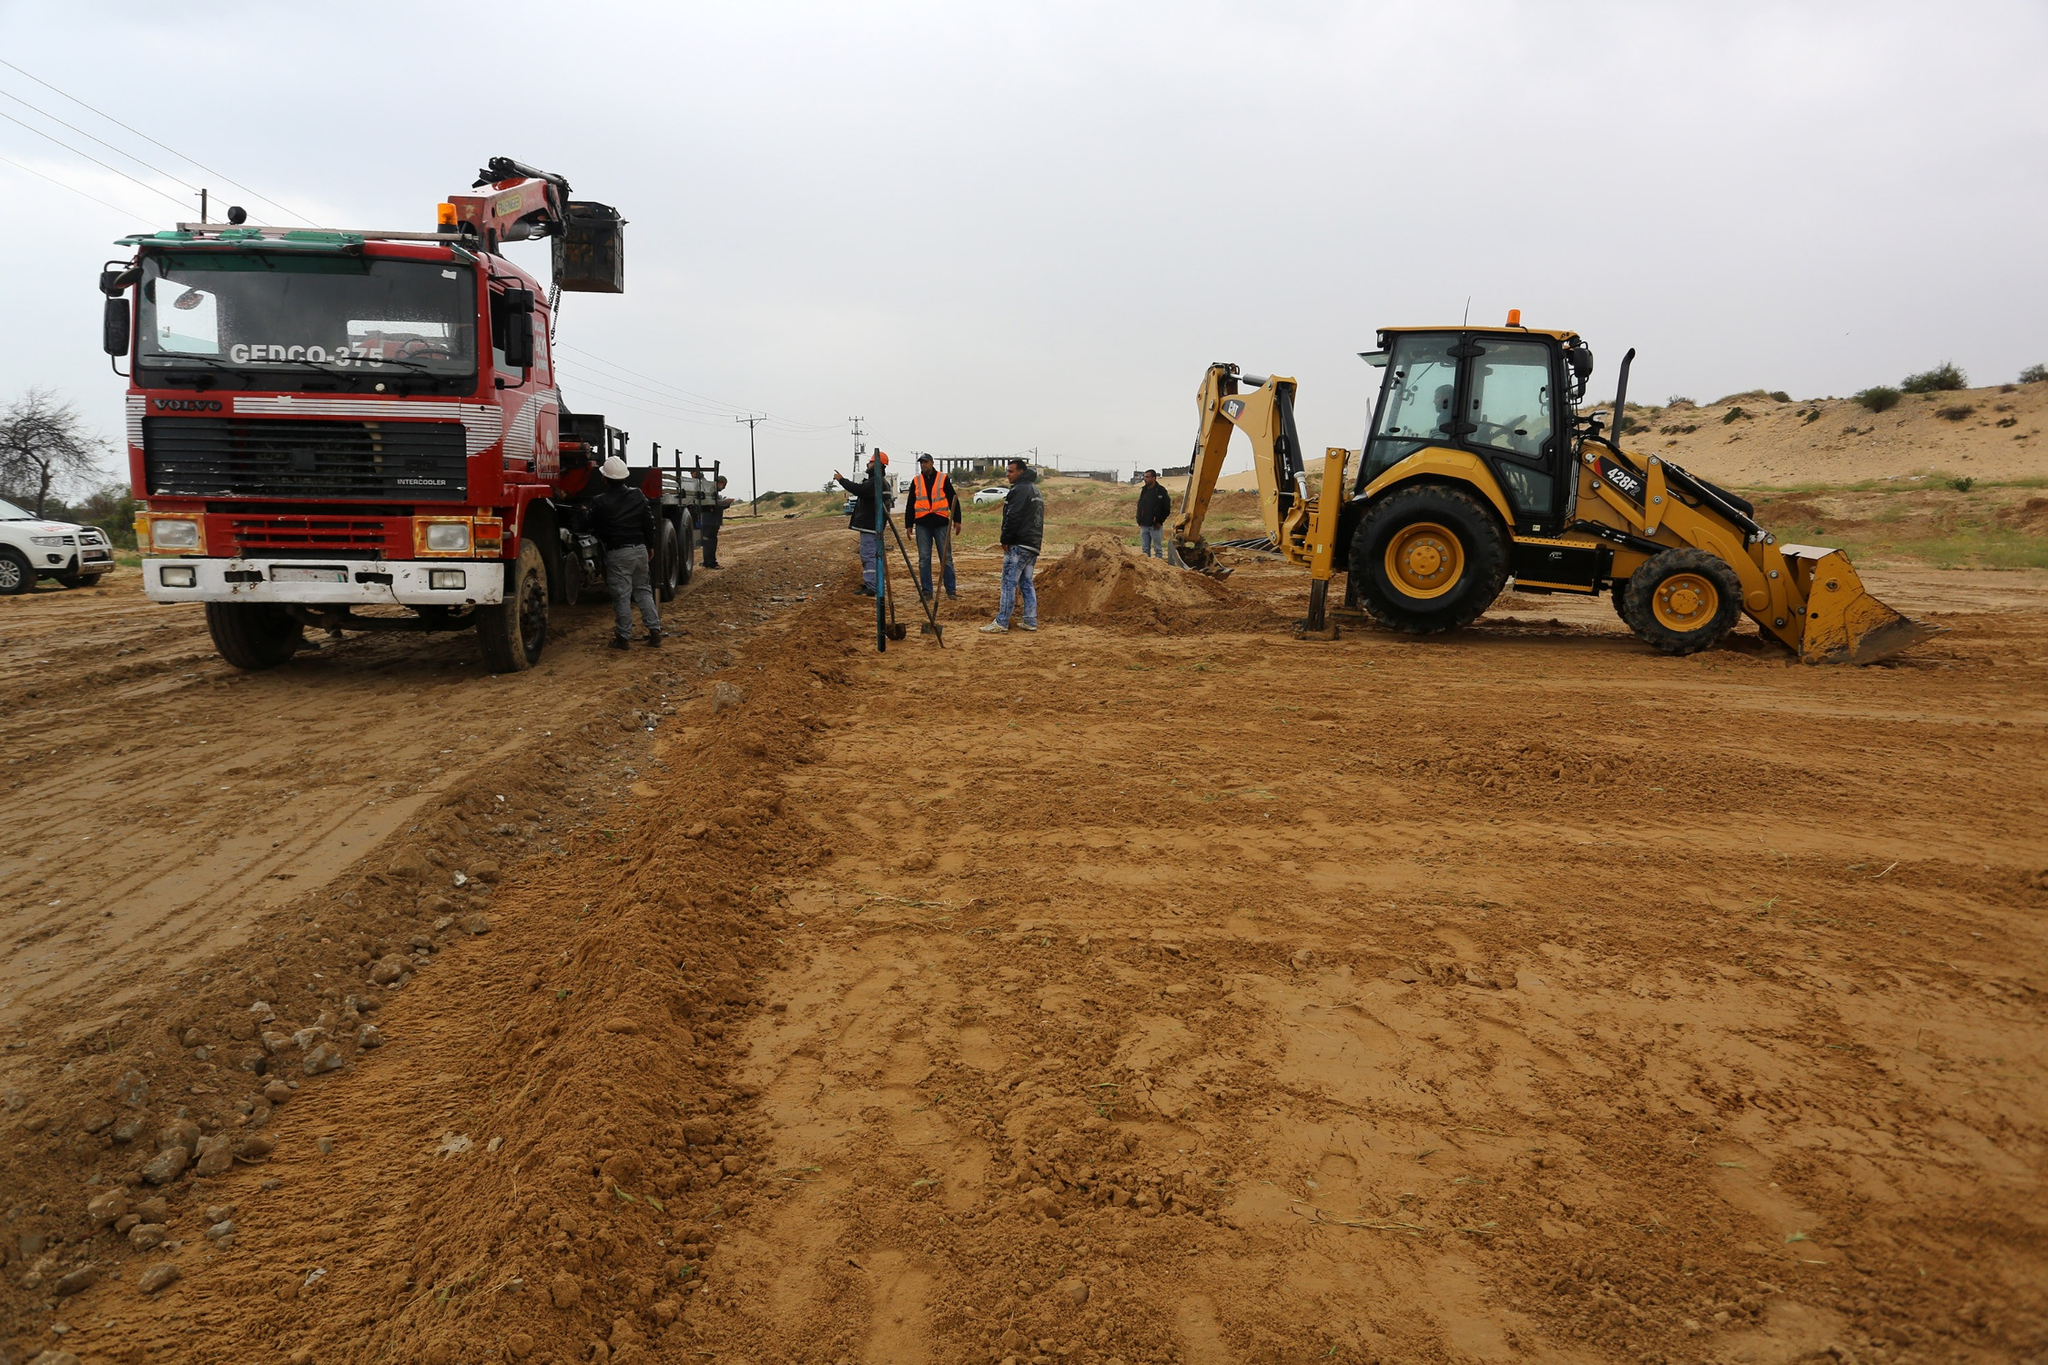Can you describe what kind of construction project this might be a part of? This construction site likely represents a large-scale infrastructure project, such as a new road or highway development. The presence of heavy machinery like the crane-equipped truck and the bulldozer suggests significant earth-moving and groundwork preparations. The workers might be conducting surveys or setting up structural elements, indicating the initial stages of the project. 